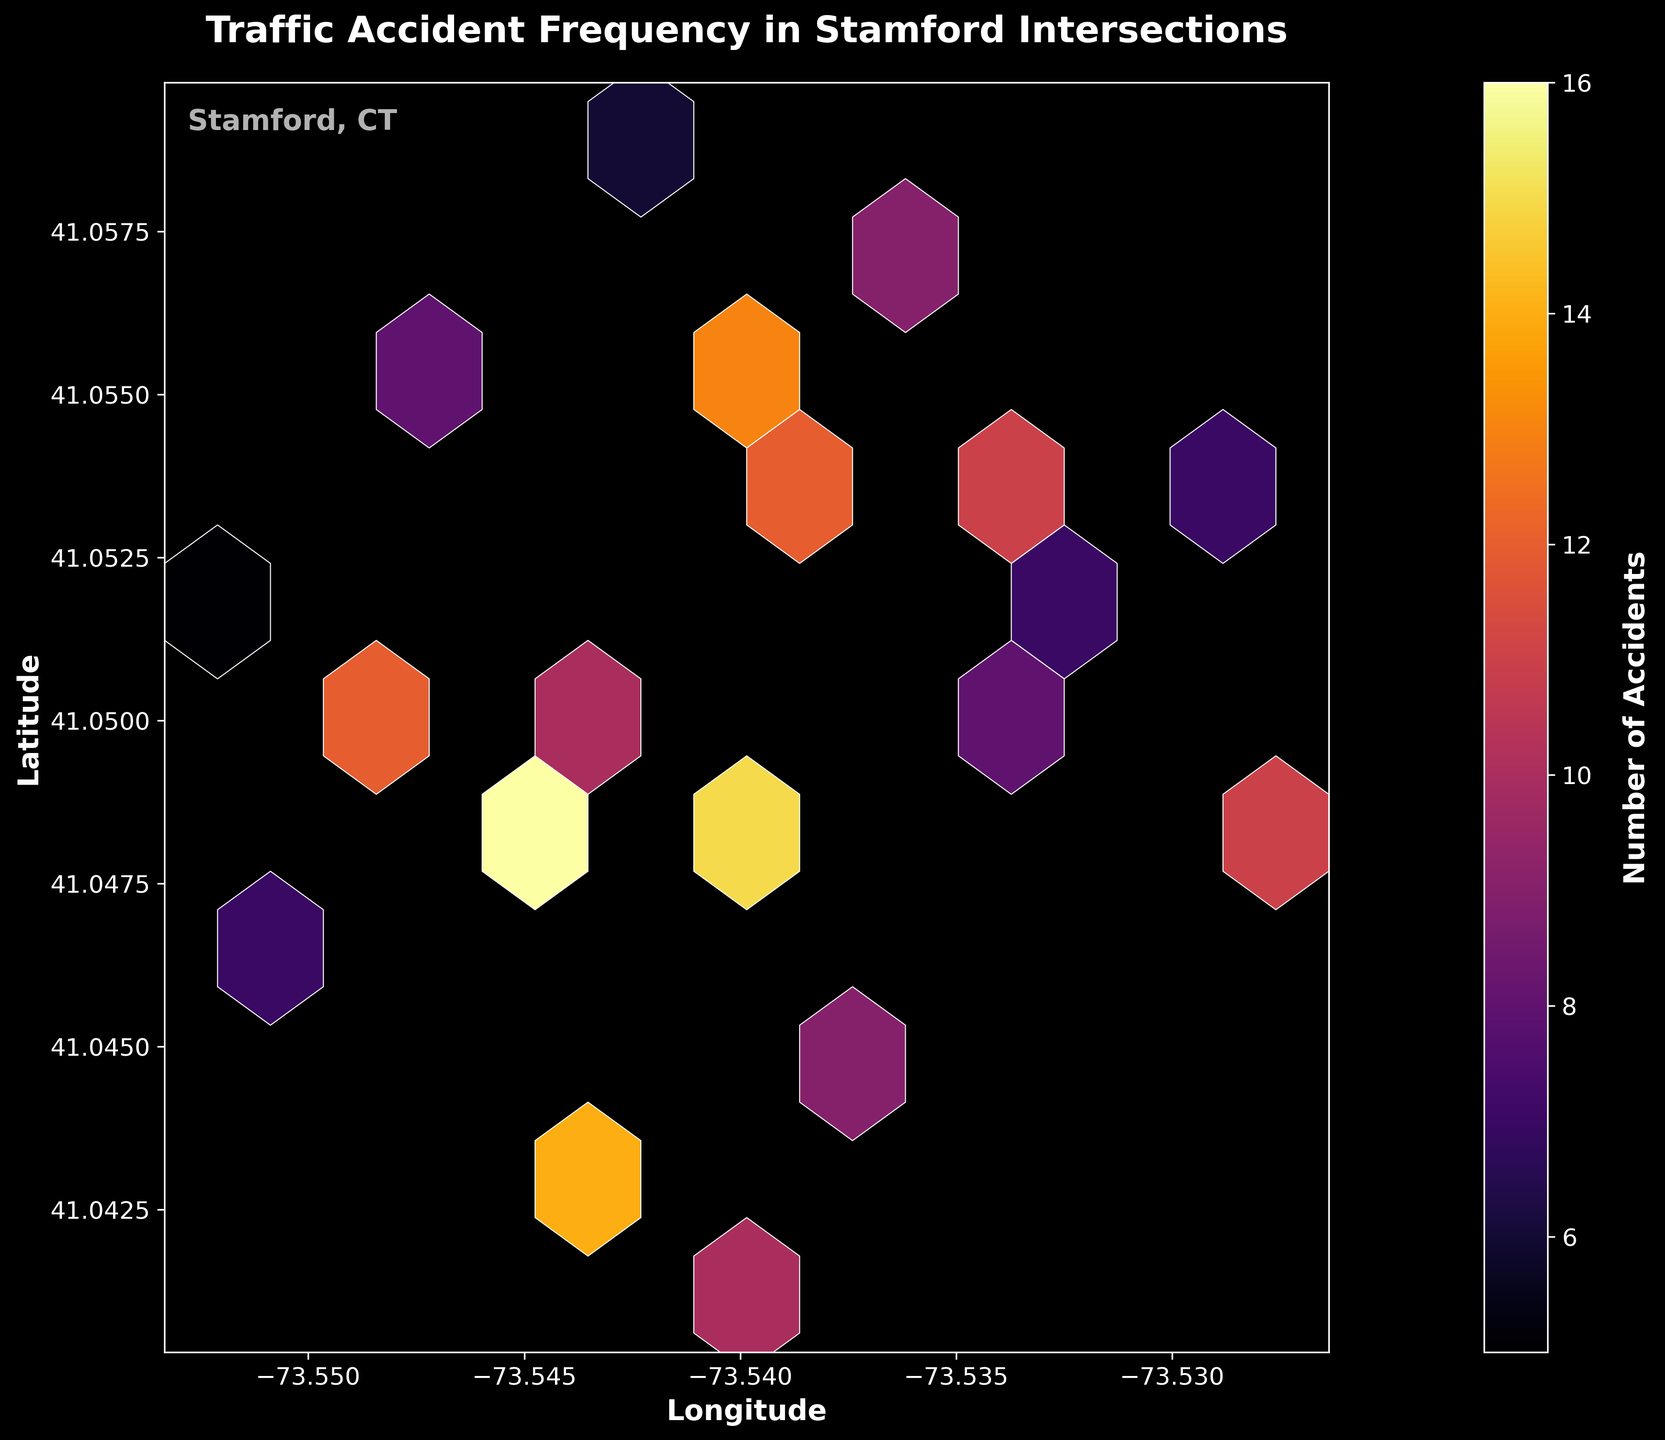What is the title of the plot? The title of the plot is located prominently at the top of the figure. This is a basic question, asking for the exact text in the title.
Answer: Traffic Accident Frequency in Stamford Intersections What do the x and y axes represent? The labels for the axes are given on the plot. This is another straightforward question. The x-axis label is "Longitude" and the y-axis label is "Latitude."
Answer: Longitude and Latitude Which color represents the highest number of accidents? According to the plot, the most intense/brightest color in the 'inferno' colormap typically represents the highest values. This can be cross-referenced with the labeled color bar.
Answer: Bright yellow What is the range of the color bar? The color bar scale is visible on the right side of the plot. It indicates the range of accident counts covered by the 'inferno' color map.
Answer: From 5 to 16 How many data points are there in total? We count the distinct data points plotted on the figure. Each hexagon represents a cluster of accidents at a geographic point, derived from the original dataset.
Answer: 20 Where is the highest accident frequency located? The hexagon with the brightest color represents the highest number of accidents. According to the colormap scale, these would be found near specific coordinates on the plot.
Answer: (-73.5456, 41.0478) Which intersection has fewer accidents: (-73.5423, 41.0589) or (-73.5521, 41.0467)? By comparing the color intensity of the hexagons at these coordinates, according to the colormap, we can determine that the hexagon over (-73.5423, 41.0589) is less intense, thus representing fewer accidents.
Answer: (-73.5423, 41.0589) What is the average count of accidents across all the intersections? To find the average, sum up all accident counts and divide by the number of intersections. Sum = 12+8+15+6+10+9+7+11+14+5+13+8+16+7+9+6+12+10+8+11 = 200. There are 20 intersections. Hence, 200/20 = 10.
Answer: 10 Is there any clustering of data points, and if so, where? A cluster is indicated by a concentration of similarly colored hexagons in a specific area. Observing the figure, there is a noticeable clustering of accidents in the central coordinates, implying several intersections with high accident frequencies.
Answer: Near the central coordinates around (-73.5456, 41.0478) What would be the median number of accidents for these intersections? To find the median, list all accident counts in order and pick the middle one. The ordered counts are 5, 6, 6, 7, 7, 8, 8, 8, 9, 9, 10, 10, 11, 11, 12, 12, 13, 14, 15, 16. There are 20 data points, so the median is the average of the 10th and 11th values: (9 + 10) / 2 = 9.5.
Answer: 9.5 